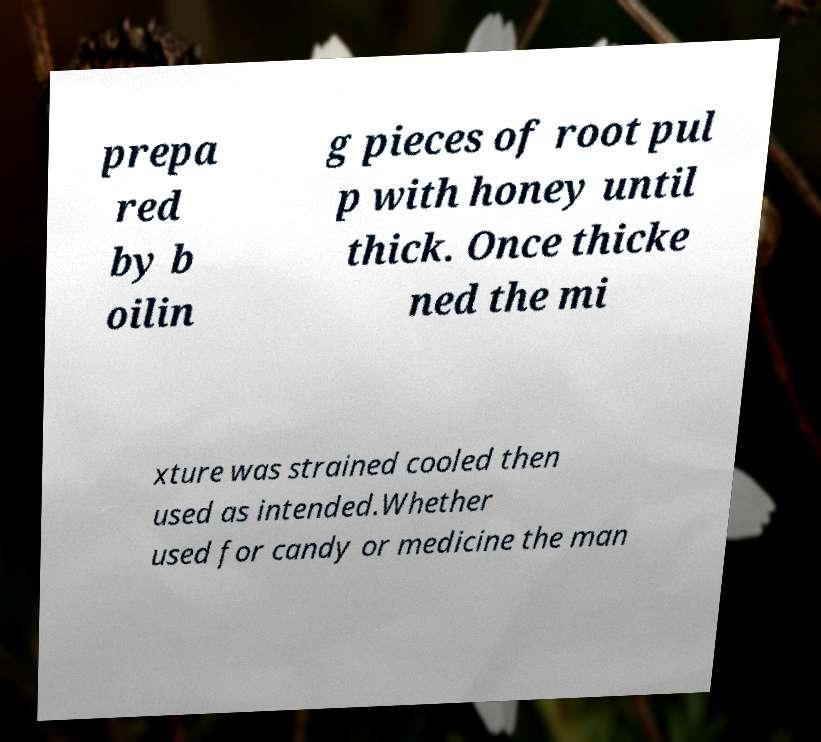Please identify and transcribe the text found in this image. prepa red by b oilin g pieces of root pul p with honey until thick. Once thicke ned the mi xture was strained cooled then used as intended.Whether used for candy or medicine the man 